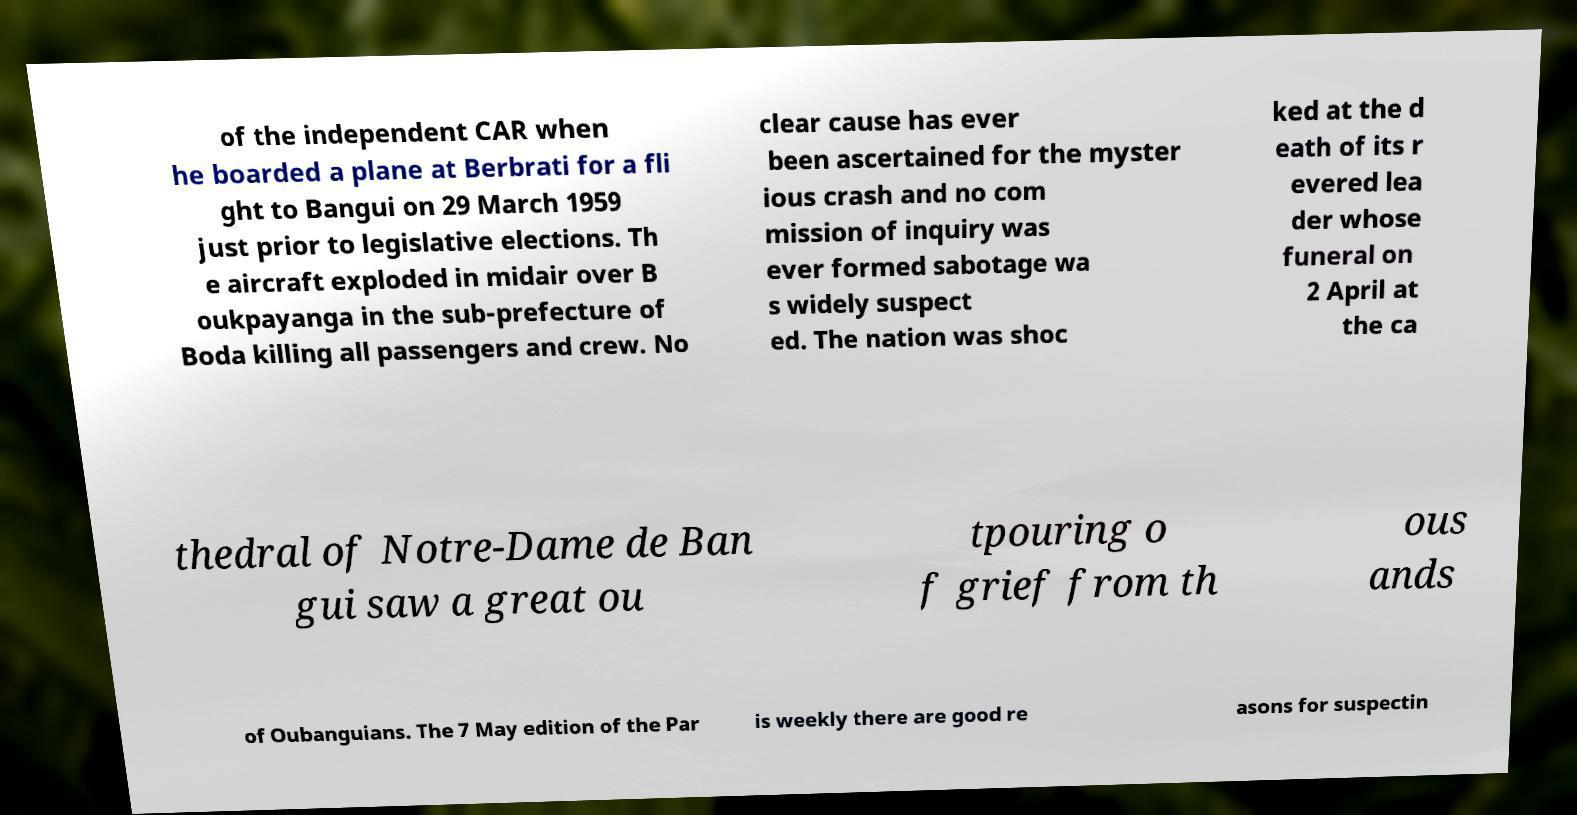Can you read and provide the text displayed in the image?This photo seems to have some interesting text. Can you extract and type it out for me? of the independent CAR when he boarded a plane at Berbrati for a fli ght to Bangui on 29 March 1959 just prior to legislative elections. Th e aircraft exploded in midair over B oukpayanga in the sub-prefecture of Boda killing all passengers and crew. No clear cause has ever been ascertained for the myster ious crash and no com mission of inquiry was ever formed sabotage wa s widely suspect ed. The nation was shoc ked at the d eath of its r evered lea der whose funeral on 2 April at the ca thedral of Notre-Dame de Ban gui saw a great ou tpouring o f grief from th ous ands of Oubanguians. The 7 May edition of the Par is weekly there are good re asons for suspectin 